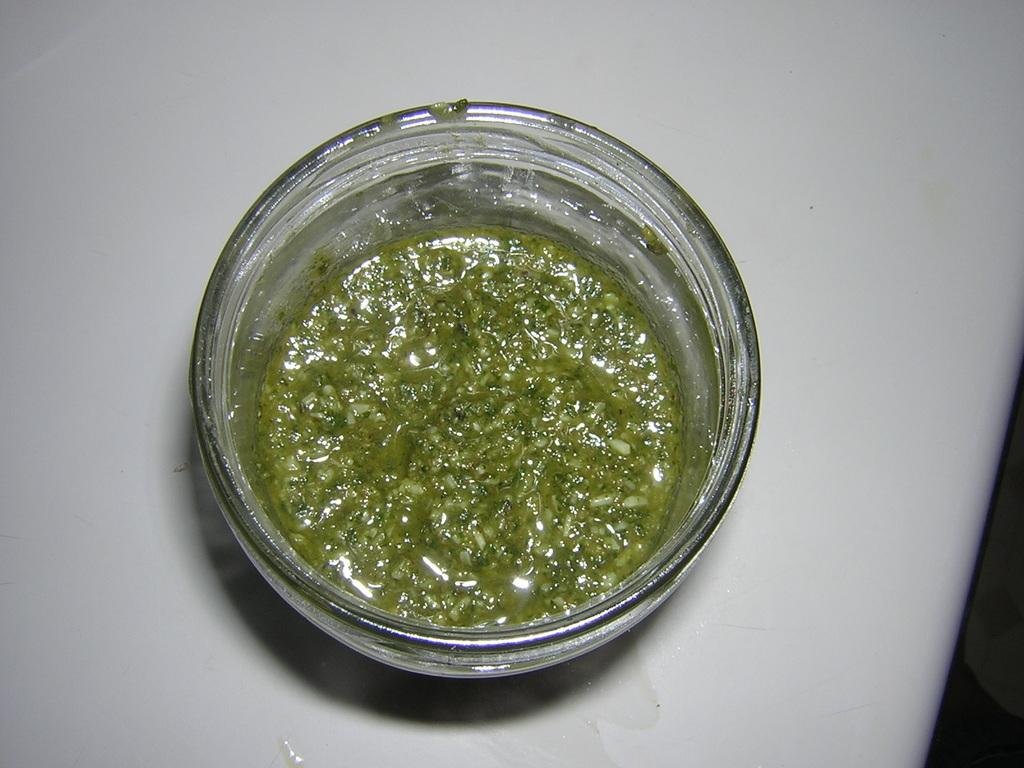What is the primary color of the surface in the image? The surface in the image is white. What object is placed on the surface? There is a glass bowl on the surface. What is inside the glass bowl? The glass bowl contains green color chutney. Can you see your mom's hands holding the chutney in the image? There is no reference to a person or hands in the image, so it is not possible to see your mom's hands holding the chutney. 